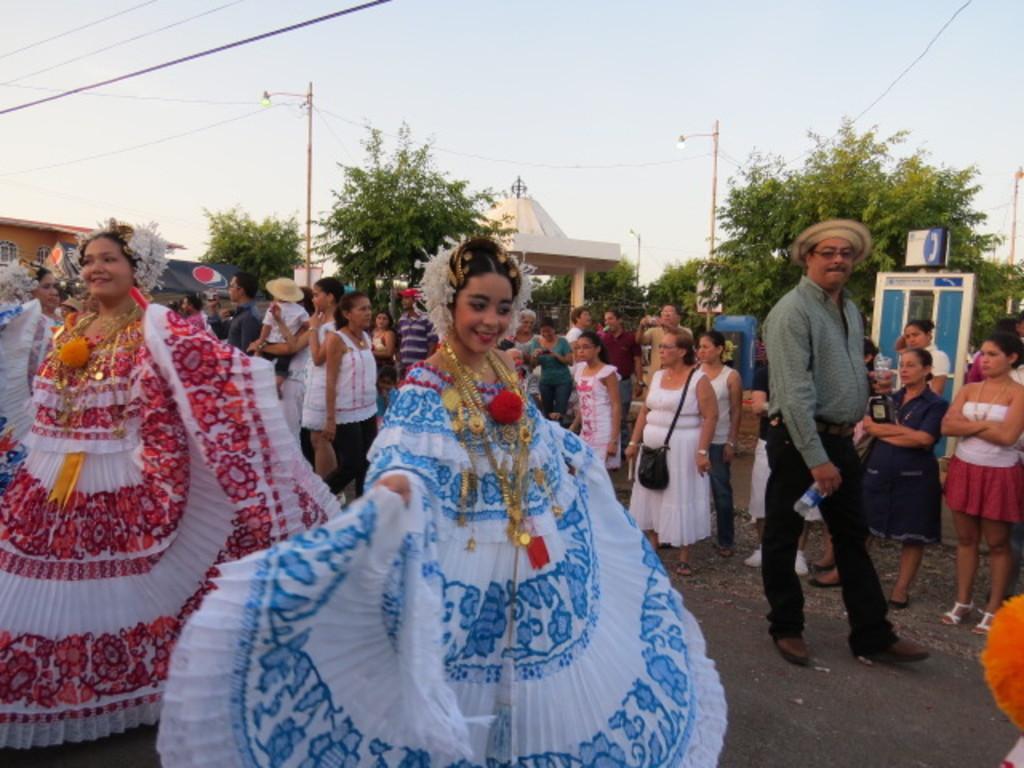How would you summarize this image in a sentence or two? This image is taken outdoors. At the top of the image there is the sky. In the background there are a few trees. There are a few poles with street lights and there is a roof with pillars. On the left side of the image there is a building and a few people are standing on the road. A woman is with a different type of costume. Many people are standing on the road and a few are walking. In the middle of the image there is a woman performing on the road and she is with a different type of costume. 